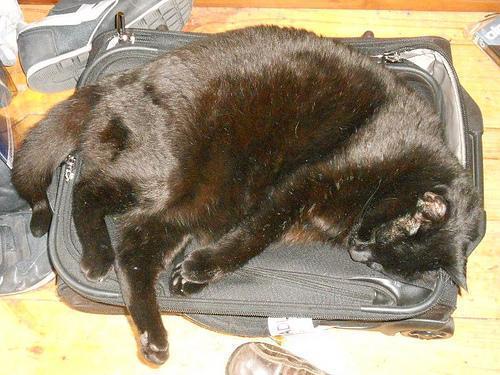How many cats are in the picture?
Give a very brief answer. 1. 